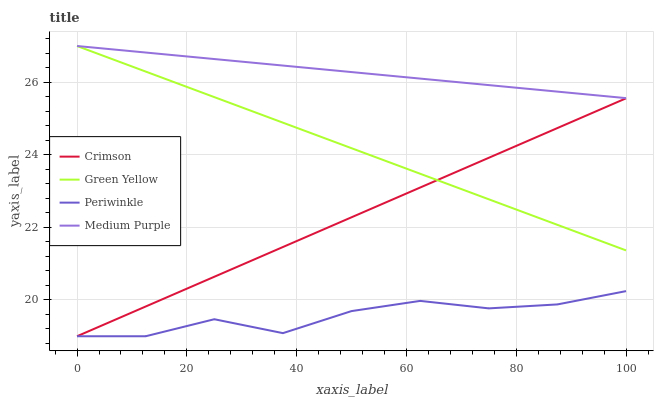Does Periwinkle have the minimum area under the curve?
Answer yes or no. Yes. Does Medium Purple have the maximum area under the curve?
Answer yes or no. Yes. Does Green Yellow have the minimum area under the curve?
Answer yes or no. No. Does Green Yellow have the maximum area under the curve?
Answer yes or no. No. Is Green Yellow the smoothest?
Answer yes or no. Yes. Is Periwinkle the roughest?
Answer yes or no. Yes. Is Medium Purple the smoothest?
Answer yes or no. No. Is Medium Purple the roughest?
Answer yes or no. No. Does Green Yellow have the lowest value?
Answer yes or no. No. Does Green Yellow have the highest value?
Answer yes or no. Yes. Does Periwinkle have the highest value?
Answer yes or no. No. Is Crimson less than Medium Purple?
Answer yes or no. Yes. Is Medium Purple greater than Periwinkle?
Answer yes or no. Yes. Does Green Yellow intersect Crimson?
Answer yes or no. Yes. Is Green Yellow less than Crimson?
Answer yes or no. No. Is Green Yellow greater than Crimson?
Answer yes or no. No. Does Crimson intersect Medium Purple?
Answer yes or no. No. 